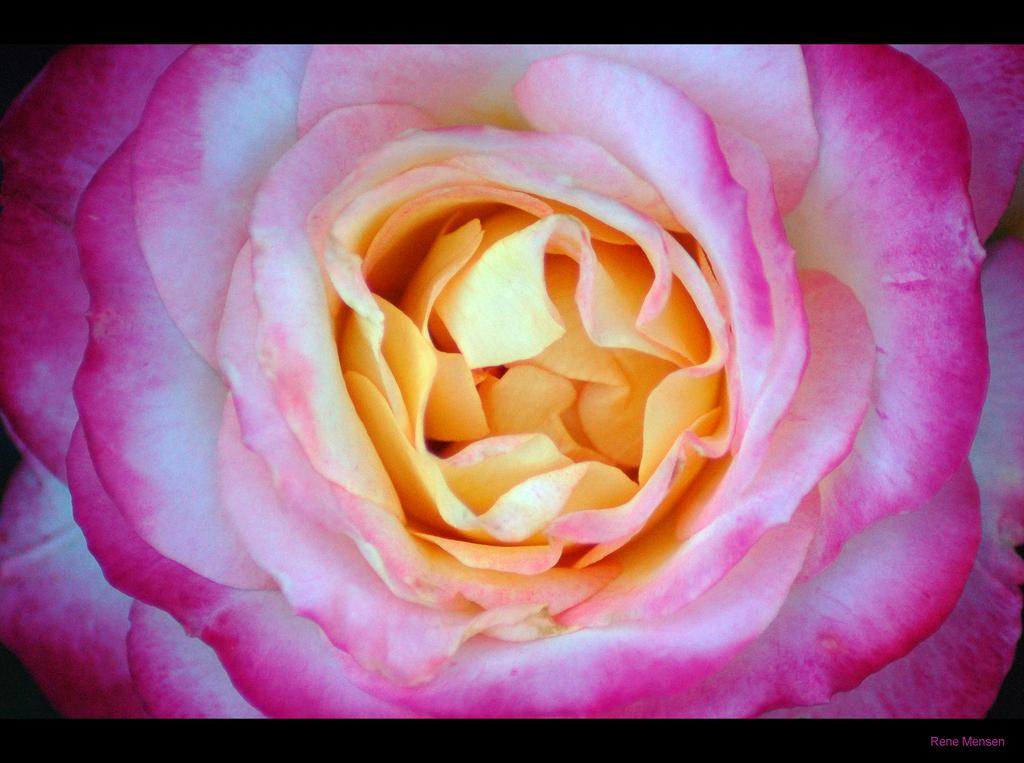What type of flower is in the image? There is a rose flower in the image. What colors are present at the top and bottom of the image? The top and bottom of the image are black in color. Where is the watermark located in the image? The watermark is in the bottom right corner of the image. Can you see the kitten's tongue sticking out in the image? There is no kitten present in the image, so its tongue cannot be seen. How many balls are visible in the image? There are no balls visible in the image. 